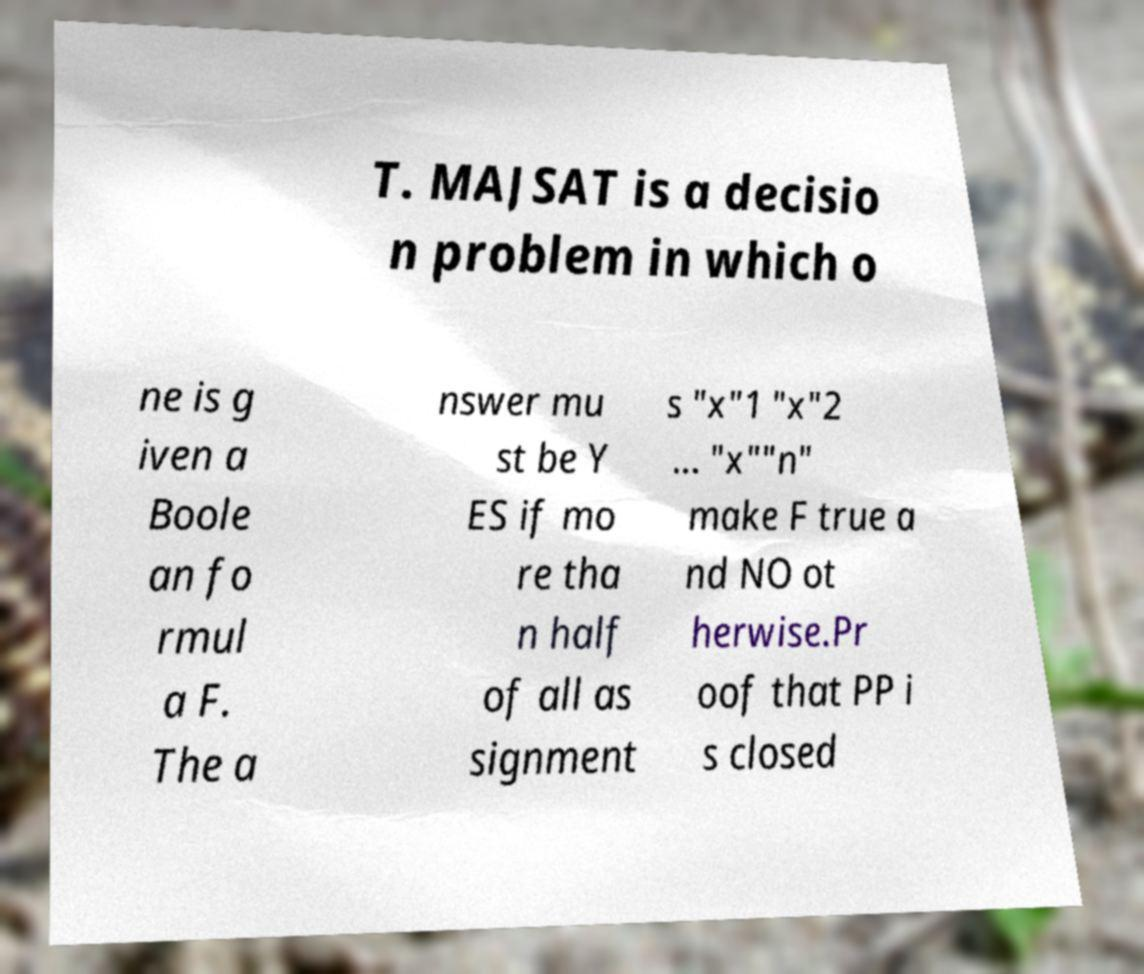Can you read and provide the text displayed in the image?This photo seems to have some interesting text. Can you extract and type it out for me? T. MAJSAT is a decisio n problem in which o ne is g iven a Boole an fo rmul a F. The a nswer mu st be Y ES if mo re tha n half of all as signment s "x"1 "x"2 ... "x""n" make F true a nd NO ot herwise.Pr oof that PP i s closed 